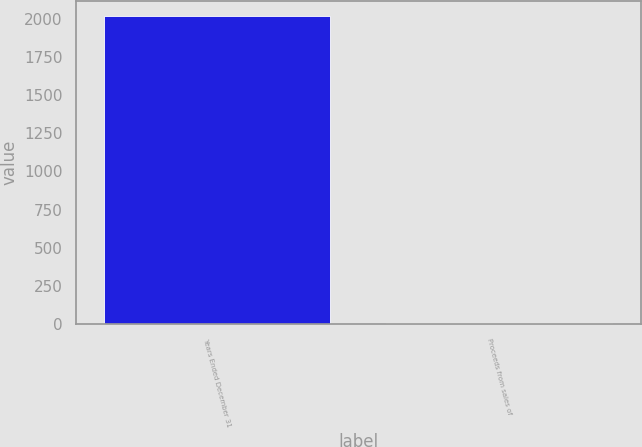Convert chart to OTSL. <chart><loc_0><loc_0><loc_500><loc_500><bar_chart><fcel>Years Ended December 31<fcel>Proceeds from sales of<nl><fcel>2014<fcel>8<nl></chart> 